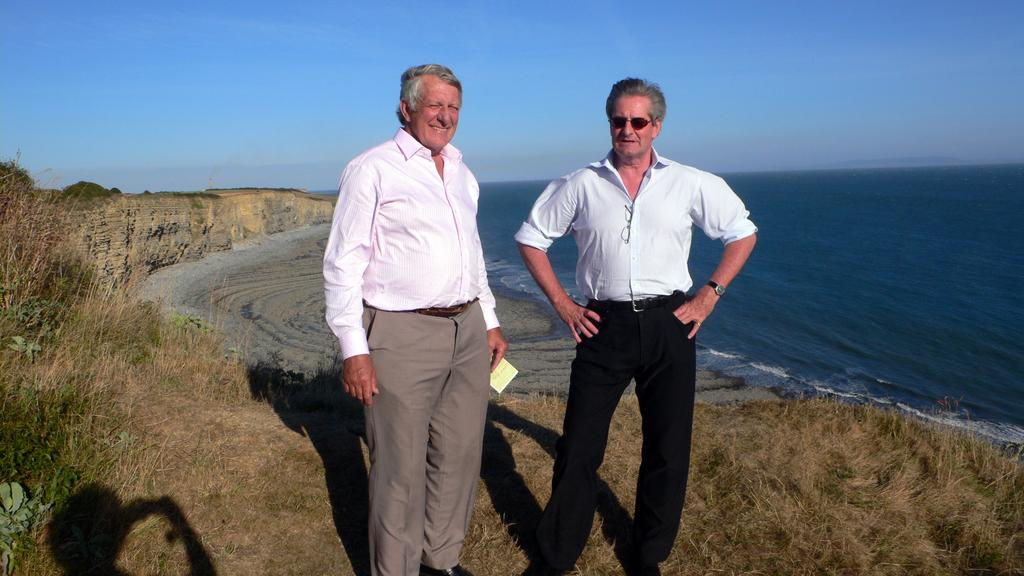How many people are in the image? There are two people standing in the center of the image. What is at the bottom of the image? There is grass at the bottom of the image. What can be seen in the background of the image? There is water in the background of the image. What is visible above the people and the grass? The sky is visible in the image. What type of toothpaste is being used by the people in the image? There is no toothpaste present in the image; it features two people standing in the grass with water in the background and the sky visible above. 